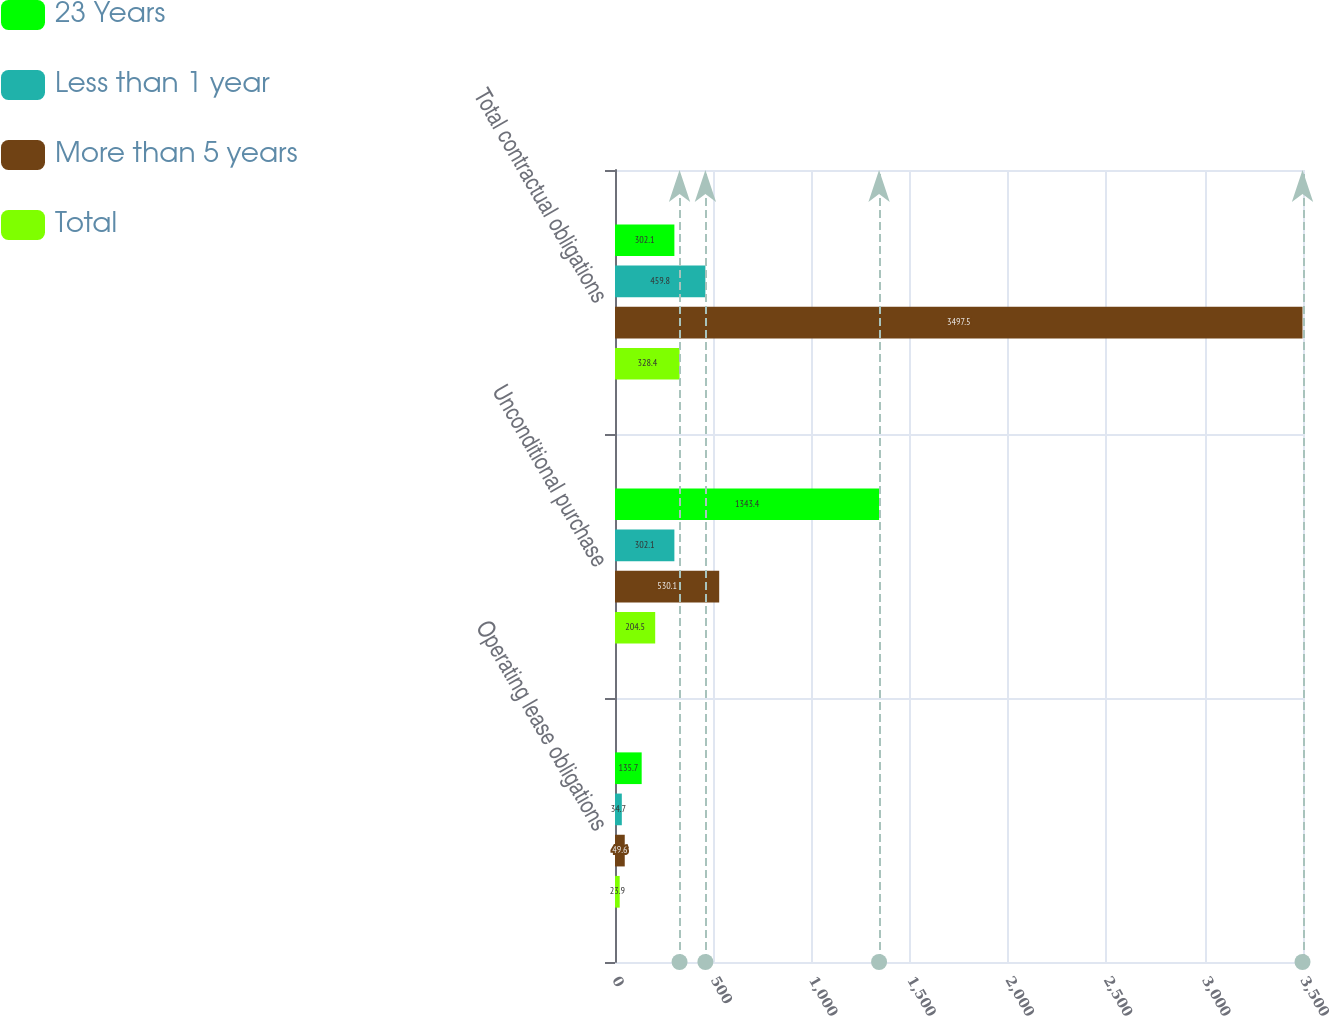Convert chart to OTSL. <chart><loc_0><loc_0><loc_500><loc_500><stacked_bar_chart><ecel><fcel>Operating lease obligations<fcel>Unconditional purchase<fcel>Total contractual obligations<nl><fcel>23 Years<fcel>135.7<fcel>1343.4<fcel>302.1<nl><fcel>Less than 1 year<fcel>34.7<fcel>302.1<fcel>459.8<nl><fcel>More than 5 years<fcel>49.6<fcel>530.1<fcel>3497.5<nl><fcel>Total<fcel>23.9<fcel>204.5<fcel>328.4<nl></chart> 